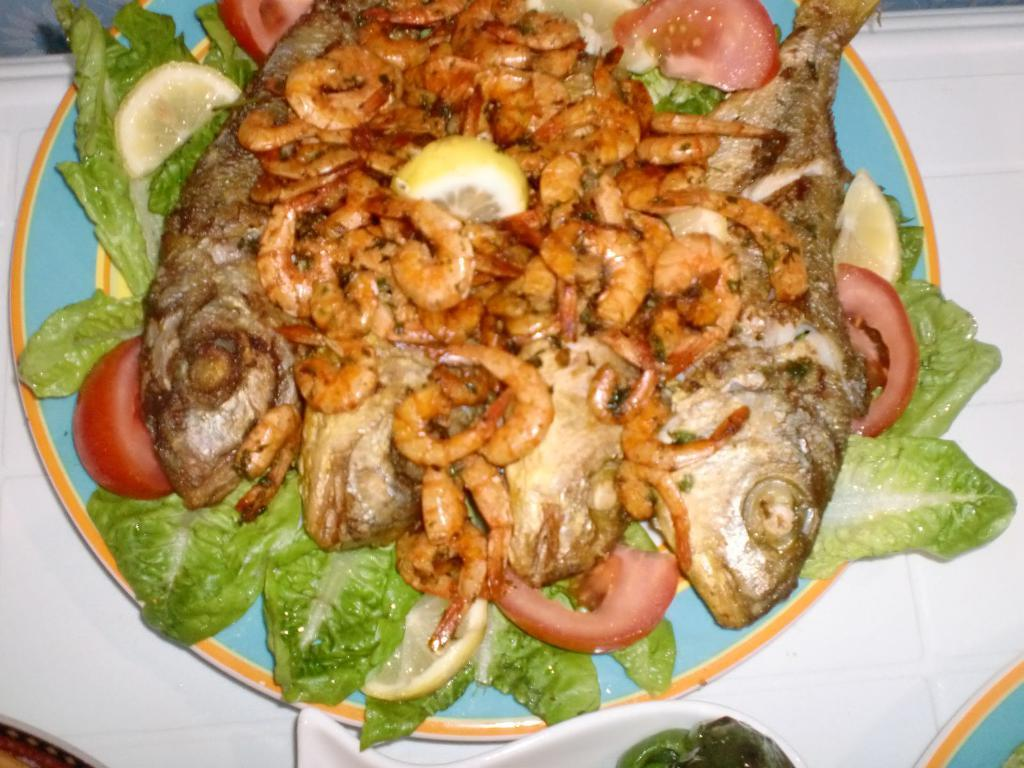What is on the plate that is visible in the image? There are fishes and prawns on the plate. Are there any other items on the plate besides the fishes and prawns? Yes, there are other unspecified items on the plate. What type of plough is being used to prepare the dish on the plate? There is no plough present in the image, and the dish on the plate does not require a plough for preparation. 